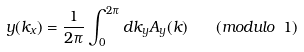Convert formula to latex. <formula><loc_0><loc_0><loc_500><loc_500>y ( k _ { x } ) = \frac { 1 } { 2 \pi } \int _ { 0 } ^ { 2 \pi } d k _ { y } A _ { y } ( k ) \quad ( m o d u l o \ 1 )</formula> 